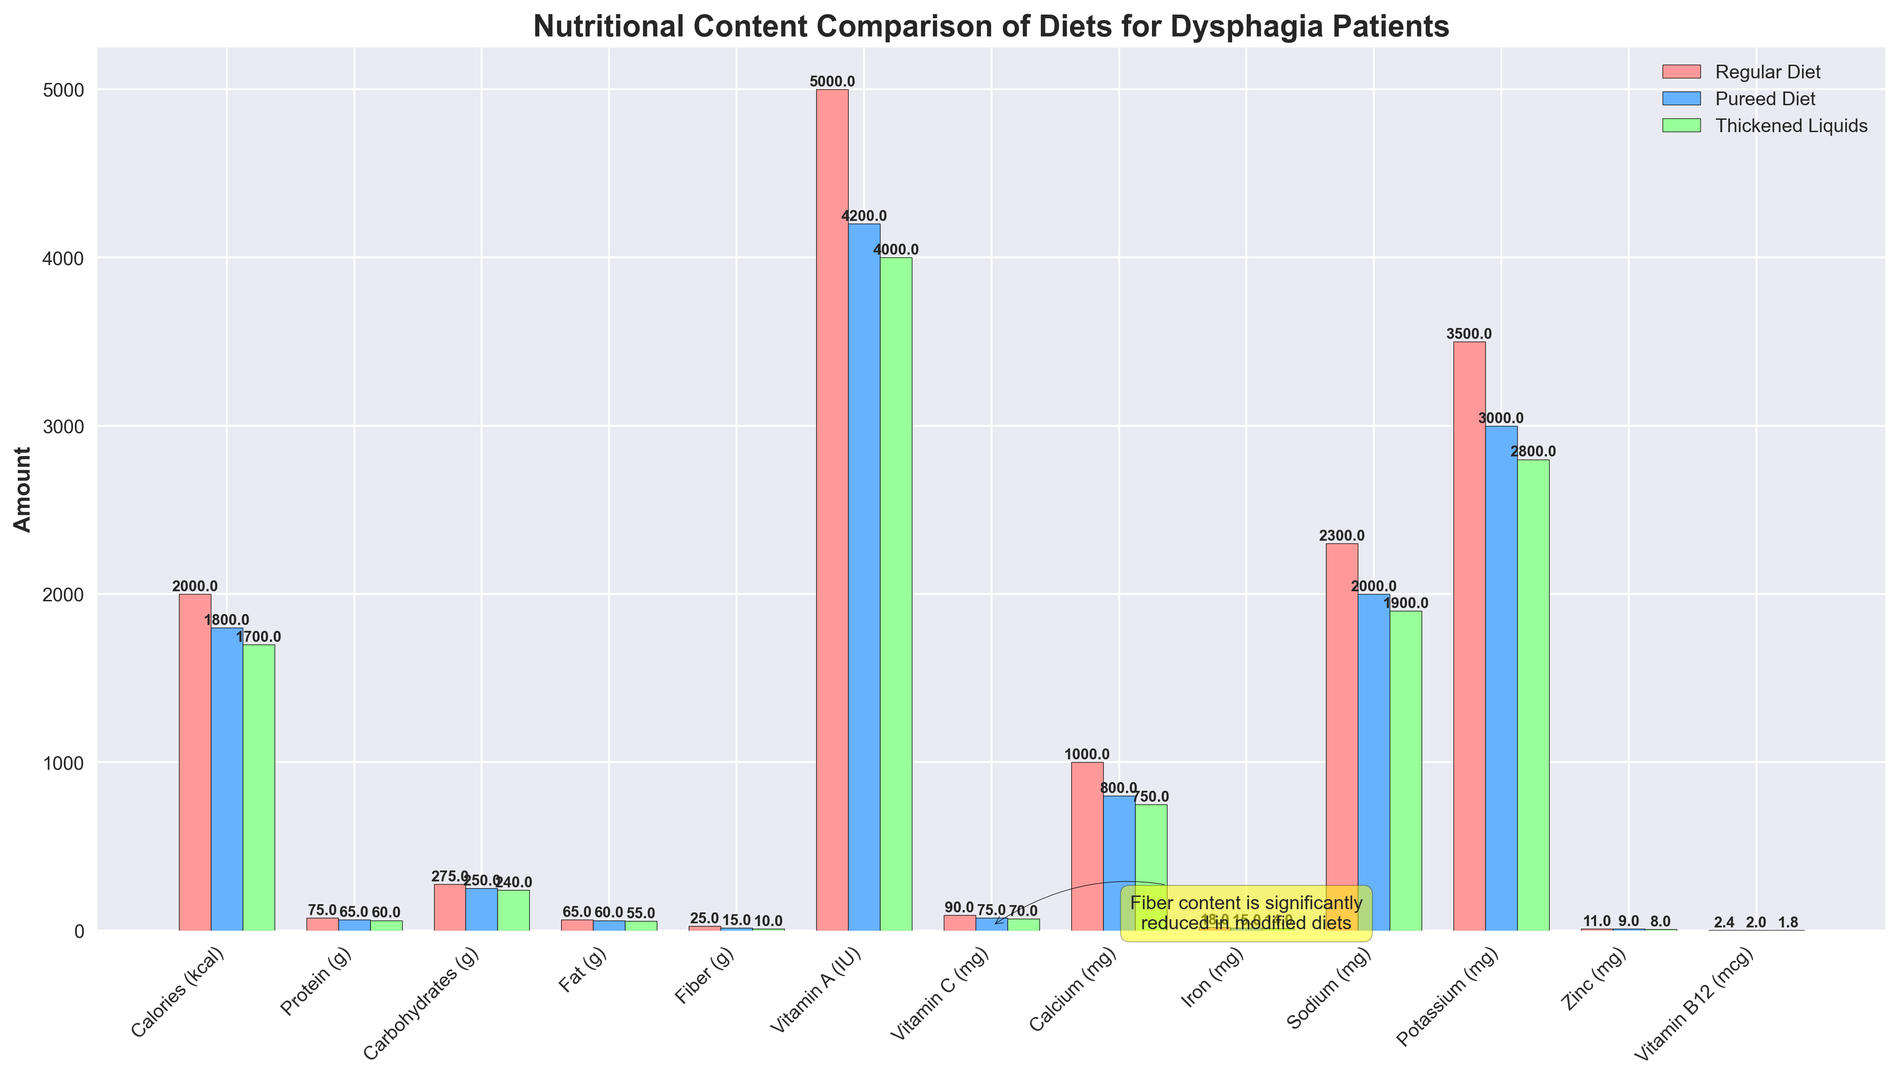Which diet has the highest protein content? To find this, look at the protein content for each diet in the figure. The Regular Diet has the highest protein content of 75 grams compared to Pureed and Thickened Liquids.
Answer: Regular Diet How much more fiber does the Regular Diet have compared to the Pureed Diet? To find the difference in fiber content, subtract the fiber content of the Pureed Diet from that of the Regular Diet: 25g - 15g = 10g.
Answer: 10g Which nutrient shows the largest difference in amount between the Regular Diet and the Thickened Liquids? We need to compare the differences for each nutrient by subtracting the Thickened Liquids value from the Regular Diet value and identifying the highest difference. The largest difference is in Fiber: 25g - 10g = 15g.
Answer: Fiber What is the average carbohydrate content across all three diets? Add the carbohydrate contents of the three diets then divide by three: (275g + 250g + 240g) / 3 = 765g / 3 = 255g.
Answer: 255g Which diet has the lowest sodium content? Check the sodium content for each diet in the figure. The Thickened Liquids diet has the lowest sodium content at 1900 mg compared to the other two diets.
Answer: Thickened Liquids Is the Vitamin C content higher in the Regular Diet or the Pureed Diet? Compare the Vitamin C content values between Regular Diet (90 mg) and Pureed Diet (75 mg). Regular Diet has higher Vitamin C content.
Answer: Regular Diet What is the total calcium content for all three diets combined? Sum the calcium content from all three diets: 1000 mg (Regular) + 800 mg (Pureed) + 750 mg (Thickened Liquids) = 2550 mg.
Answer: 2550 mg By how much does the protein content decrease from the Regular Diet to the Thickened Liquids? Subtract the protein content of the Thickened Liquids from the Regular Diet: 75g - 60g = 15g.
Answer: 15g Which diet has the highest number of nutrients that are greater in quantity compared to one or both of the other diets? Compare each nutrient across the three diets and count the number of times a diet has a higher value. The Regular Diet has the highest number of nutrients which are greater compared to one or both other diets.
Answer: Regular Diet 